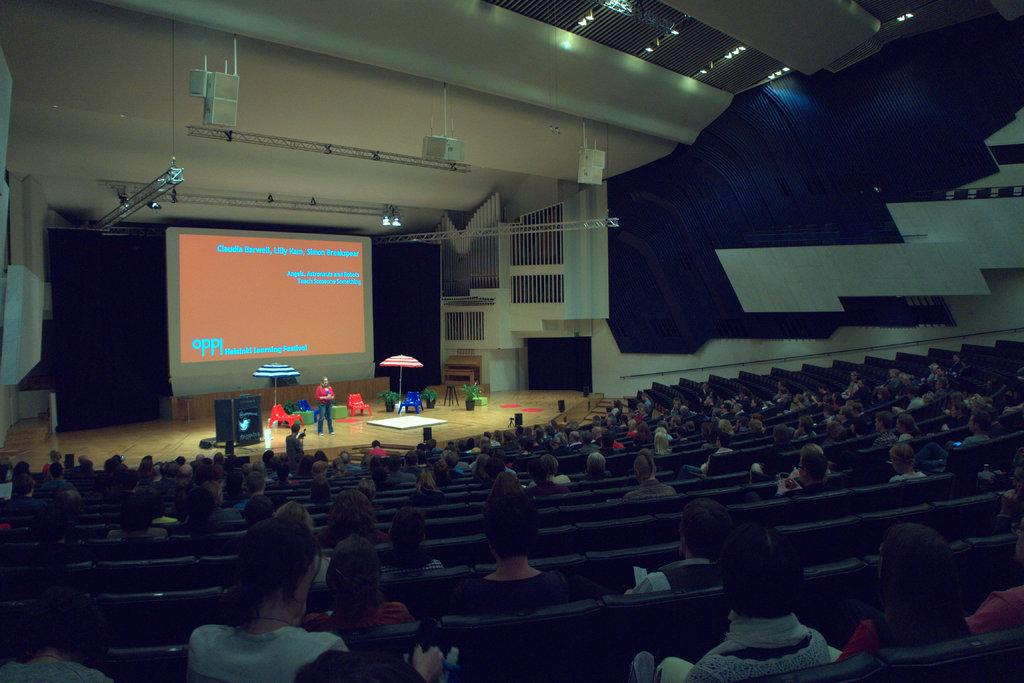<image>
Describe the image concisely. a projection screen in a auditorium for the oppl learning festival 